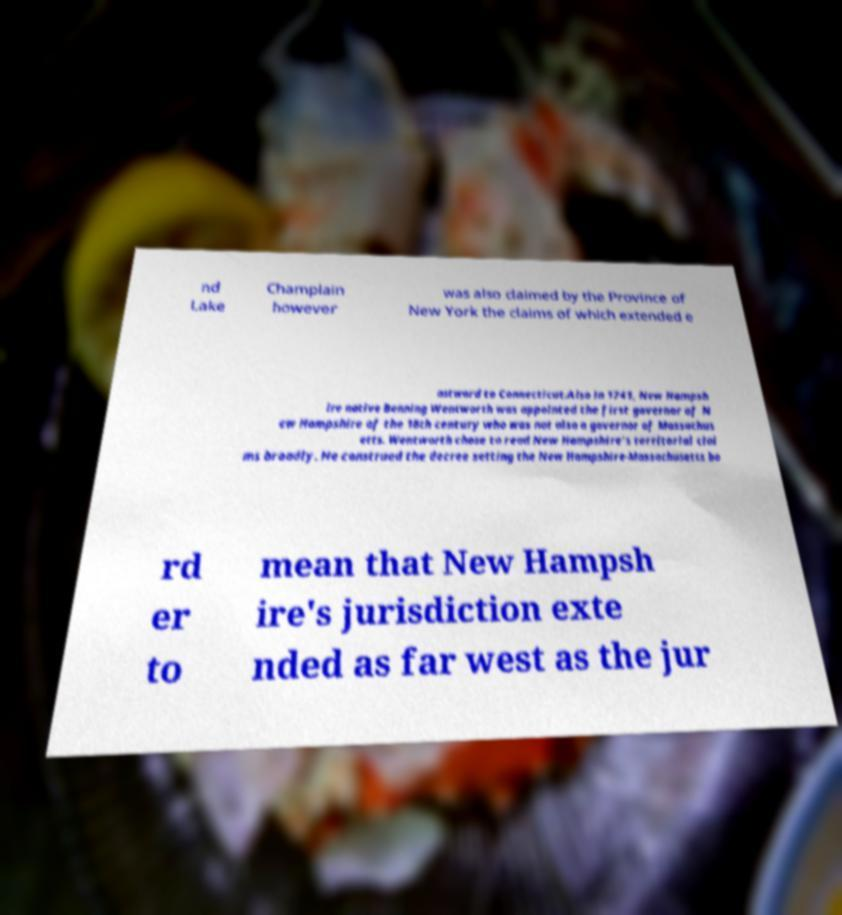Can you read and provide the text displayed in the image?This photo seems to have some interesting text. Can you extract and type it out for me? nd Lake Champlain however was also claimed by the Province of New York the claims of which extended e astward to Connecticut.Also in 1741, New Hampsh ire native Benning Wentworth was appointed the first governor of N ew Hampshire of the 18th century who was not also a governor of Massachus etts. Wentworth chose to read New Hampshire's territorial clai ms broadly. He construed the decree setting the New Hampshire-Massachusetts bo rd er to mean that New Hampsh ire's jurisdiction exte nded as far west as the jur 